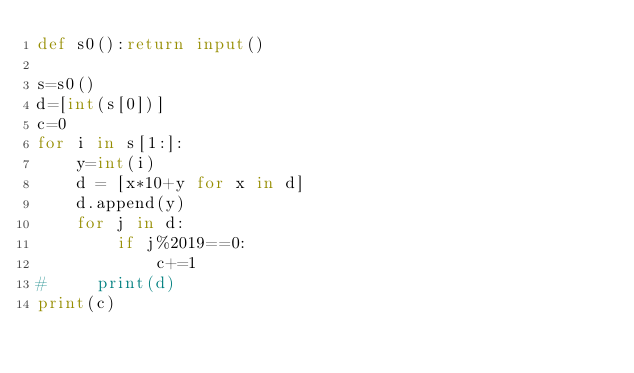<code> <loc_0><loc_0><loc_500><loc_500><_Python_>def s0():return input()

s=s0()
d=[int(s[0])]
c=0
for i in s[1:]:
    y=int(i)
    d = [x*10+y for x in d]
    d.append(y)
    for j in d:
        if j%2019==0:
            c+=1
#     print(d)
print(c)</code> 